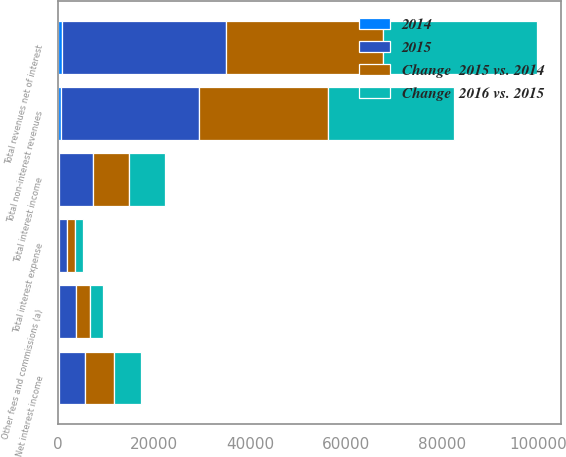<chart> <loc_0><loc_0><loc_500><loc_500><stacked_bar_chart><ecel><fcel>Other fees and commissions (a)<fcel>Total non-interest revenues<fcel>Total interest income<fcel>Total interest expense<fcel>Net interest income<fcel>Total revenues net of interest<nl><fcel>Change  2016 vs. 2015<fcel>2753<fcel>26348<fcel>7475<fcel>1704<fcel>5771<fcel>32119<nl><fcel>Change  2015 vs. 2014<fcel>2866<fcel>26896<fcel>7545<fcel>1623<fcel>5922<fcel>32818<nl><fcel>2015<fcel>3626<fcel>28716<fcel>7179<fcel>1707<fcel>5472<fcel>34188<nl><fcel>2014<fcel>113<fcel>548<fcel>70<fcel>81<fcel>151<fcel>699<nl></chart> 